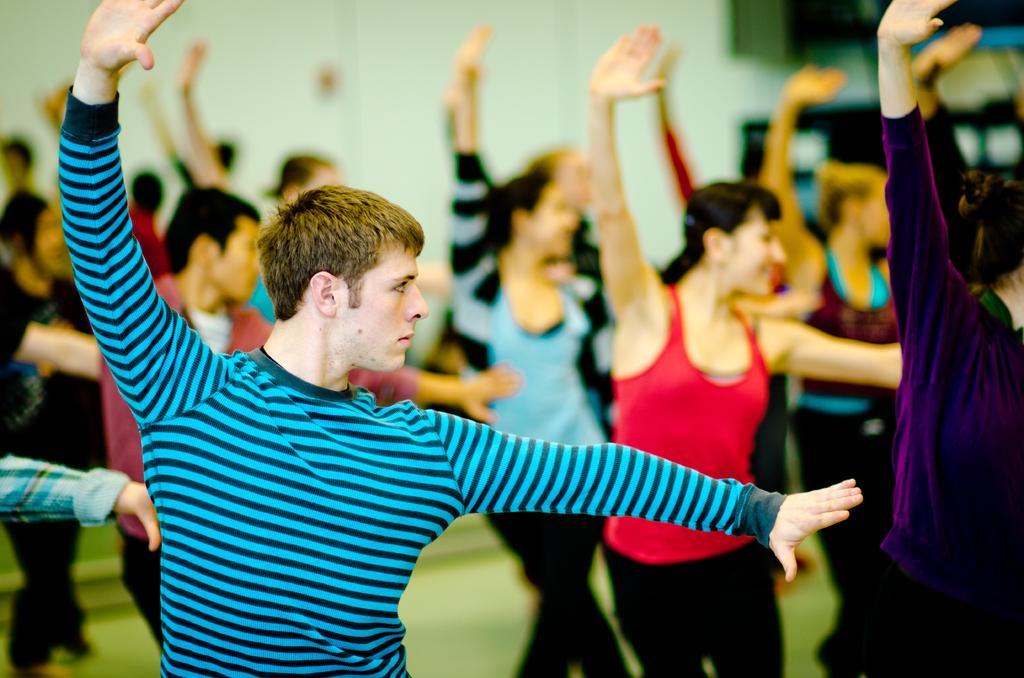What is happening in the image? There is a group of people in the image, and they are dancing on the floor. Can you describe the background of the image? The background of the image is blurred. What type of juice is being served in the image? There is no juice present in the image; it features a group of people dancing on the floor with a blurred background. 